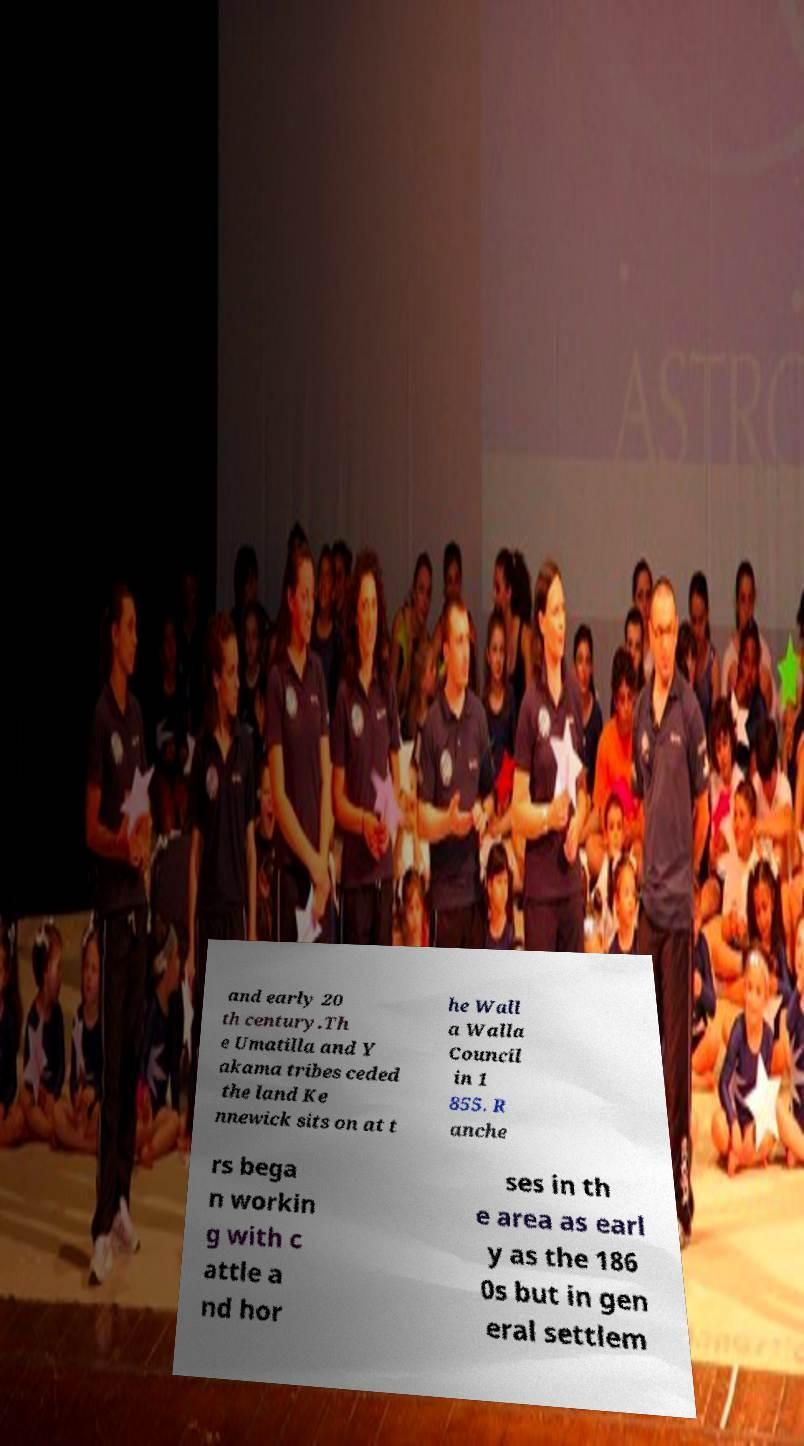Please read and relay the text visible in this image. What does it say? and early 20 th century.Th e Umatilla and Y akama tribes ceded the land Ke nnewick sits on at t he Wall a Walla Council in 1 855. R anche rs bega n workin g with c attle a nd hor ses in th e area as earl y as the 186 0s but in gen eral settlem 